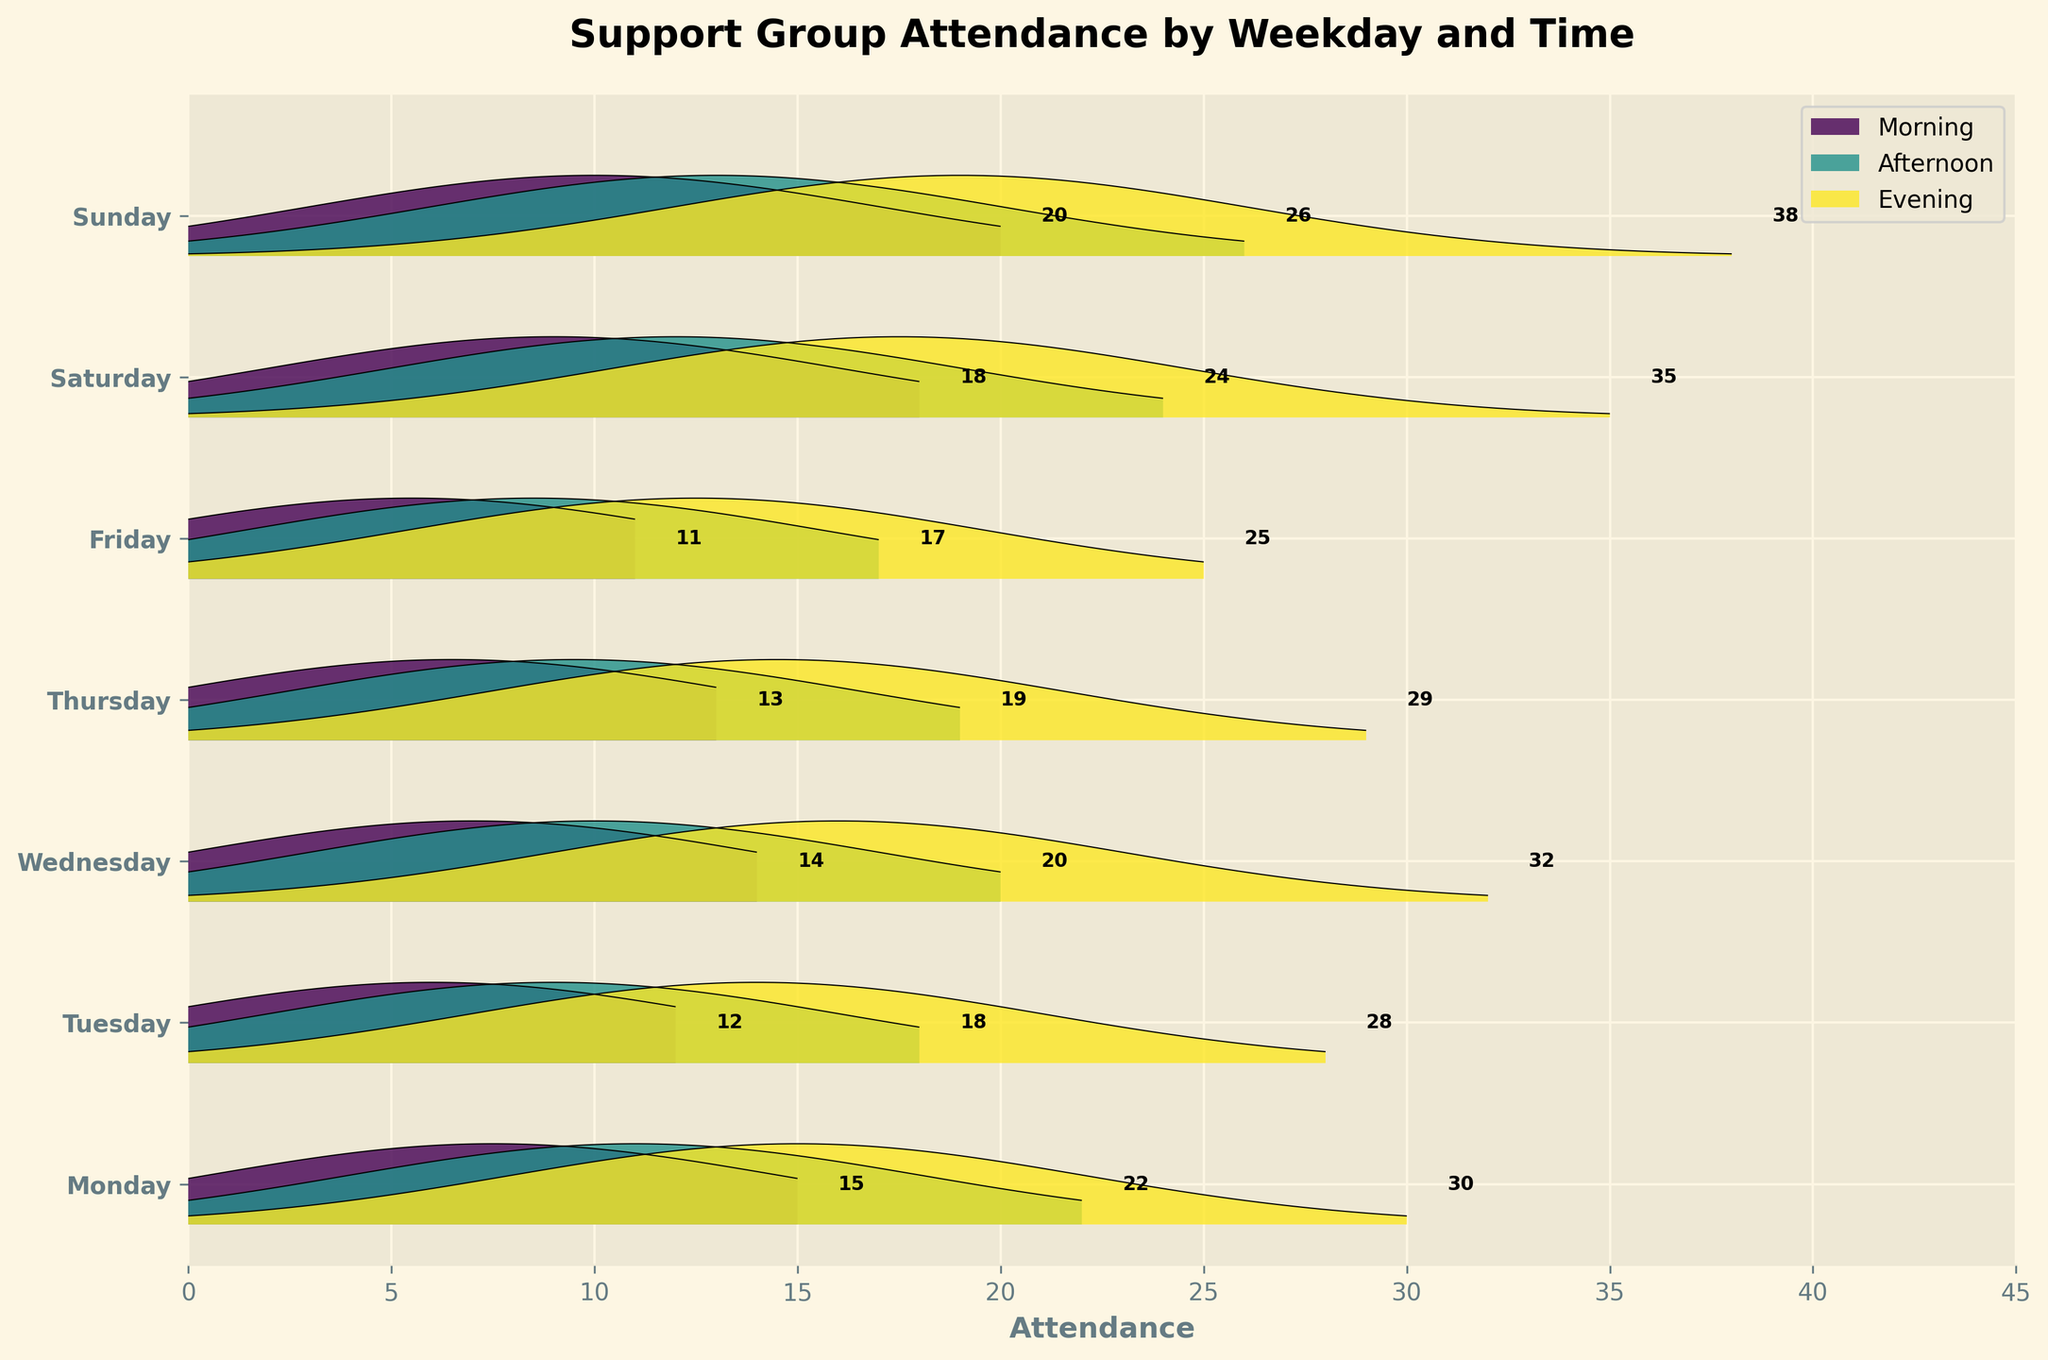What is the title of the figure? The title of the figure is usually located at the top and provides an overview of what the plot represents. Here, it says "Support Group Attendance by Weekday and Time."
Answer: Support Group Attendance by Weekday and Time What is the attendance rate on Sunday evening? Look for the curve associated with Sunday and observe the label next to the evening time. The attendance number is written just past the peak.
Answer: 38 Which weekday has the highest morning attendance rate? Look for the morning slots across all weekdays. The one with the highest peak (furthest to the right) is Sunday with a 20.
Answer: Sunday What time of the day has the highest attendance on average? Add up the attendance rates for each time slot (Morning, Afternoon, Evening) across all weekdays and divide by the number of days (7). Evening has the highest average.
Answer: Evening How does the attendance on Monday evening compare to Wednesday evening? Compare the peaks for Monday and Wednesday evenings as shown in the numbers around those curves. Monday is 30 and Wednesday is 32.
Answer: Wednesday evening has a higher attendance Which weekday has the lowest overall attendance? Sum the attendance across Morning, Afternoon, and Evening for each weekday. The day with the smallest total is Friday.
Answer: Friday What is the average attendance rate in the evenings during the week? Total the evening attendance rates (30, 28, 32, 29, 25, 35, 38) and divide by 7. This gives the average.
Answer: 31 On which day is the afternoon attendance highest? Look at the attendance rates for the afternoon slots of each day. Sunday has the highest at 26.
Answer: Sunday How does attendance vary throughout the day on Saturdays? Look at the morning, afternoon, and evening slots for Saturday. The values are 18, 24, and 35, respectively. Attendance increases from morning to evening.
Answer: Increases from morning to evening Which day's afternoon attendance is closest to the evening attendance on the same day? Compare the afternoon and evening attendances of each day. Thursday has 19 for afternoon and 29 for evening, which have a difference of 10.
Answer: Thursday 